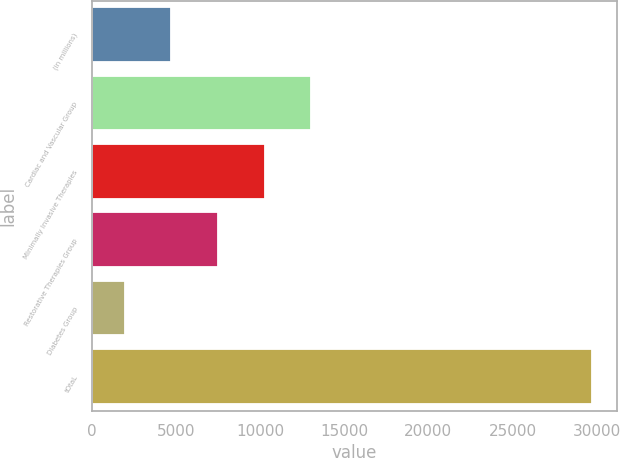Convert chart to OTSL. <chart><loc_0><loc_0><loc_500><loc_500><bar_chart><fcel>(in millions)<fcel>Cardiac and Vascular Group<fcel>Minimally Invasive Therapies<fcel>Restorative Therapies Group<fcel>Diabetes Group<fcel>tOtaL<nl><fcel>4705.3<fcel>13040.2<fcel>10261.9<fcel>7483.6<fcel>1927<fcel>29710<nl></chart> 